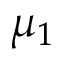<formula> <loc_0><loc_0><loc_500><loc_500>\mu _ { 1 }</formula> 